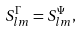<formula> <loc_0><loc_0><loc_500><loc_500>S _ { l m } ^ { \Gamma } = S _ { l m } ^ { \Psi } ,</formula> 